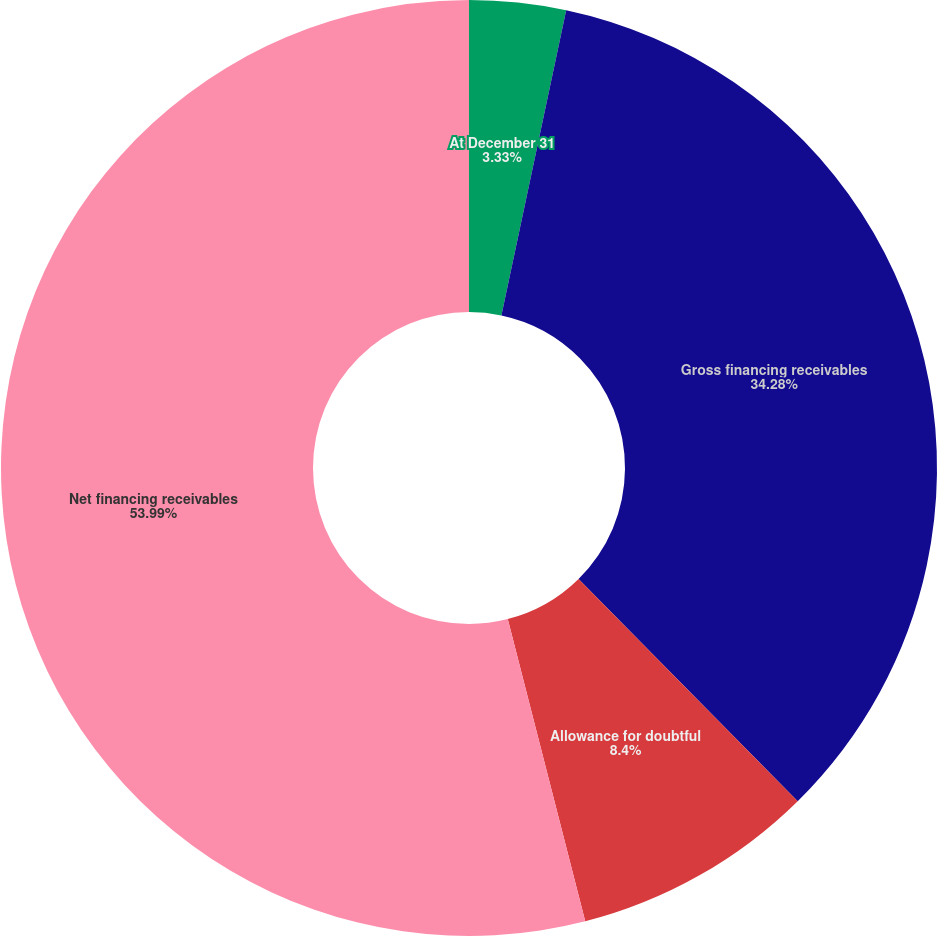<chart> <loc_0><loc_0><loc_500><loc_500><pie_chart><fcel>At December 31<fcel>Gross financing receivables<fcel>Allowance for doubtful<fcel>Net financing receivables<nl><fcel>3.33%<fcel>34.28%<fcel>8.4%<fcel>54.0%<nl></chart> 